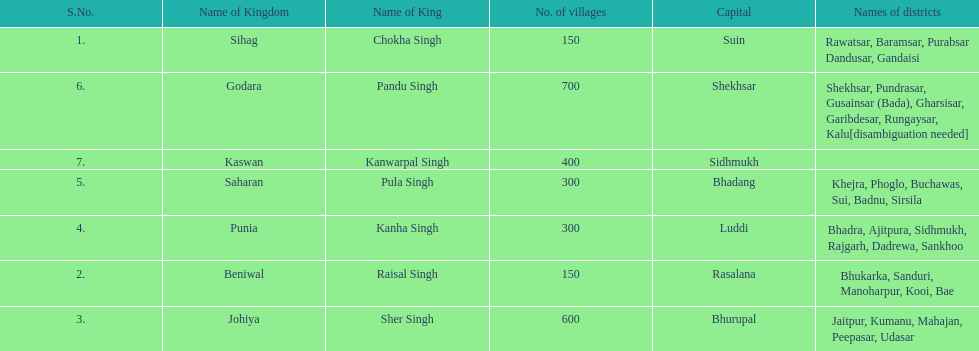What is the number of kingdoms that have more than 300 villages? 3. 